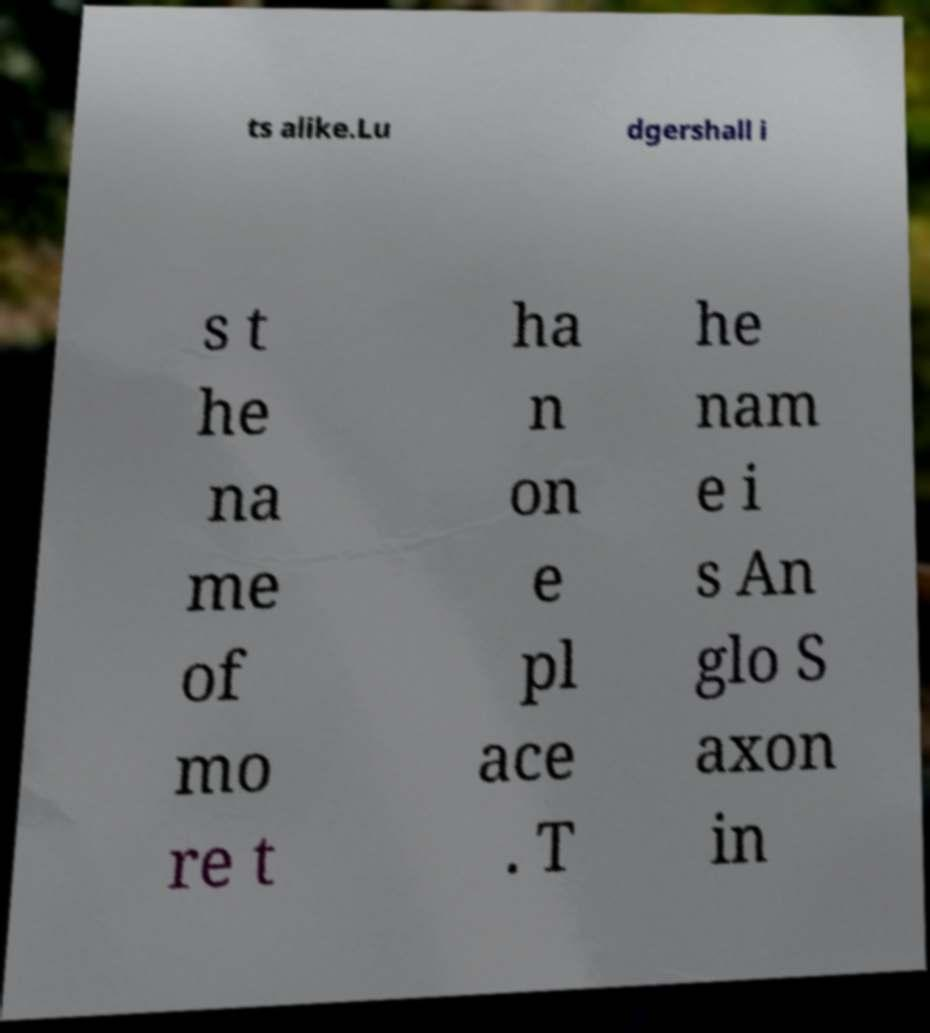There's text embedded in this image that I need extracted. Can you transcribe it verbatim? ts alike.Lu dgershall i s t he na me of mo re t ha n on e pl ace . T he nam e i s An glo S axon in 